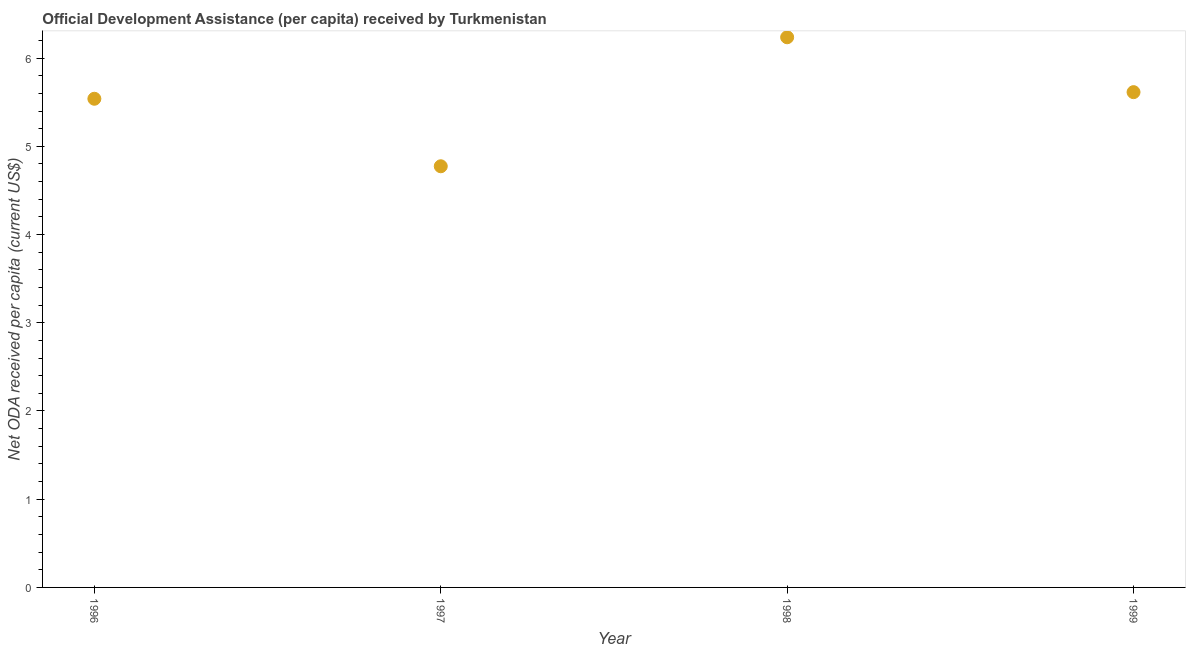What is the net oda received per capita in 1998?
Keep it short and to the point. 6.24. Across all years, what is the maximum net oda received per capita?
Offer a terse response. 6.24. Across all years, what is the minimum net oda received per capita?
Your answer should be very brief. 4.77. In which year was the net oda received per capita maximum?
Provide a succinct answer. 1998. In which year was the net oda received per capita minimum?
Offer a terse response. 1997. What is the sum of the net oda received per capita?
Make the answer very short. 22.16. What is the difference between the net oda received per capita in 1996 and 1998?
Ensure brevity in your answer.  -0.7. What is the average net oda received per capita per year?
Your answer should be very brief. 5.54. What is the median net oda received per capita?
Provide a short and direct response. 5.58. In how many years, is the net oda received per capita greater than 0.6000000000000001 US$?
Your answer should be very brief. 4. What is the ratio of the net oda received per capita in 1997 to that in 1999?
Your answer should be very brief. 0.85. Is the net oda received per capita in 1996 less than that in 1999?
Give a very brief answer. Yes. Is the difference between the net oda received per capita in 1997 and 1998 greater than the difference between any two years?
Make the answer very short. Yes. What is the difference between the highest and the second highest net oda received per capita?
Offer a very short reply. 0.62. Is the sum of the net oda received per capita in 1997 and 1999 greater than the maximum net oda received per capita across all years?
Ensure brevity in your answer.  Yes. What is the difference between the highest and the lowest net oda received per capita?
Offer a very short reply. 1.46. In how many years, is the net oda received per capita greater than the average net oda received per capita taken over all years?
Offer a terse response. 2. How many dotlines are there?
Offer a very short reply. 1. How many years are there in the graph?
Your answer should be very brief. 4. What is the difference between two consecutive major ticks on the Y-axis?
Make the answer very short. 1. Are the values on the major ticks of Y-axis written in scientific E-notation?
Ensure brevity in your answer.  No. What is the title of the graph?
Your answer should be compact. Official Development Assistance (per capita) received by Turkmenistan. What is the label or title of the Y-axis?
Provide a succinct answer. Net ODA received per capita (current US$). What is the Net ODA received per capita (current US$) in 1996?
Provide a succinct answer. 5.54. What is the Net ODA received per capita (current US$) in 1997?
Offer a very short reply. 4.77. What is the Net ODA received per capita (current US$) in 1998?
Offer a terse response. 6.24. What is the Net ODA received per capita (current US$) in 1999?
Make the answer very short. 5.61. What is the difference between the Net ODA received per capita (current US$) in 1996 and 1997?
Keep it short and to the point. 0.77. What is the difference between the Net ODA received per capita (current US$) in 1996 and 1998?
Offer a very short reply. -0.7. What is the difference between the Net ODA received per capita (current US$) in 1996 and 1999?
Offer a very short reply. -0.07. What is the difference between the Net ODA received per capita (current US$) in 1997 and 1998?
Ensure brevity in your answer.  -1.46. What is the difference between the Net ODA received per capita (current US$) in 1997 and 1999?
Give a very brief answer. -0.84. What is the difference between the Net ODA received per capita (current US$) in 1998 and 1999?
Keep it short and to the point. 0.62. What is the ratio of the Net ODA received per capita (current US$) in 1996 to that in 1997?
Ensure brevity in your answer.  1.16. What is the ratio of the Net ODA received per capita (current US$) in 1996 to that in 1998?
Offer a terse response. 0.89. What is the ratio of the Net ODA received per capita (current US$) in 1997 to that in 1998?
Your answer should be compact. 0.77. What is the ratio of the Net ODA received per capita (current US$) in 1997 to that in 1999?
Your answer should be very brief. 0.85. What is the ratio of the Net ODA received per capita (current US$) in 1998 to that in 1999?
Offer a very short reply. 1.11. 